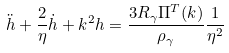Convert formula to latex. <formula><loc_0><loc_0><loc_500><loc_500>\ddot { h } + \frac { 2 } { \eta } \dot { h } + k ^ { 2 } h = \frac { 3 R _ { \gamma } \Pi ^ { T } ( k ) } { \rho _ { \gamma } } \frac { 1 } { \eta ^ { 2 } }</formula> 